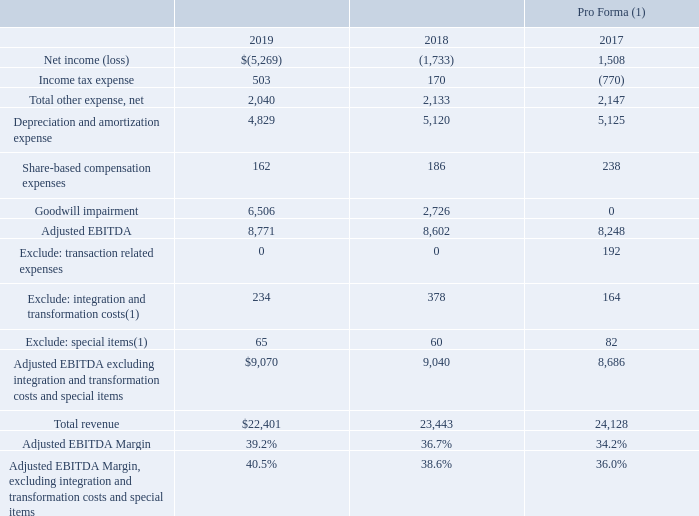Adjusted EBITDA Non-GAAP Reconciliation
(UNAUDITED)
($ in millions)
(1) Refer to Non-GAAP Integration and Transformation Costs and Special Items table for details of the integration and transformation costs and special items included above.
Which table should be referred to for details of the integration and transformation costs and special items? Non-gaap integration and transformation costs and special items table. What is the total revenue for 2019?
Answer scale should be: million. $22,401. Which items are excluded from the Adjusted EBITDA? Transaction related expenses, integration and transformation costs, special items. How many items are excluded from the Adjusted EBITDA? Transaction related expenses##integration and transformation costs##special items
answer: 3. What is the total change in the Adjusted EBITDA margin between 2019 and 2017?
Answer scale should be: percent. 39.2%-34.2%
Answer: 5. What is the average total revenue across the three years?
Answer scale should be: million. ($22,401+$23,443+$24,128)/3
Answer: 23324. 